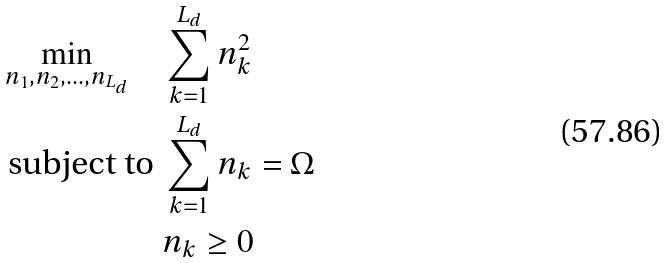Convert formula to latex. <formula><loc_0><loc_0><loc_500><loc_500>\min _ { n _ { 1 } , n _ { 2 } , \dots , n _ { L _ { d } } } \quad & \sum _ { k = 1 } ^ { L _ { d } } n _ { k } ^ { 2 } \\ \text {subject to } & \sum _ { k = 1 } ^ { L _ { d } } n _ { k } = \Omega \\ & n _ { k } \geq 0</formula> 